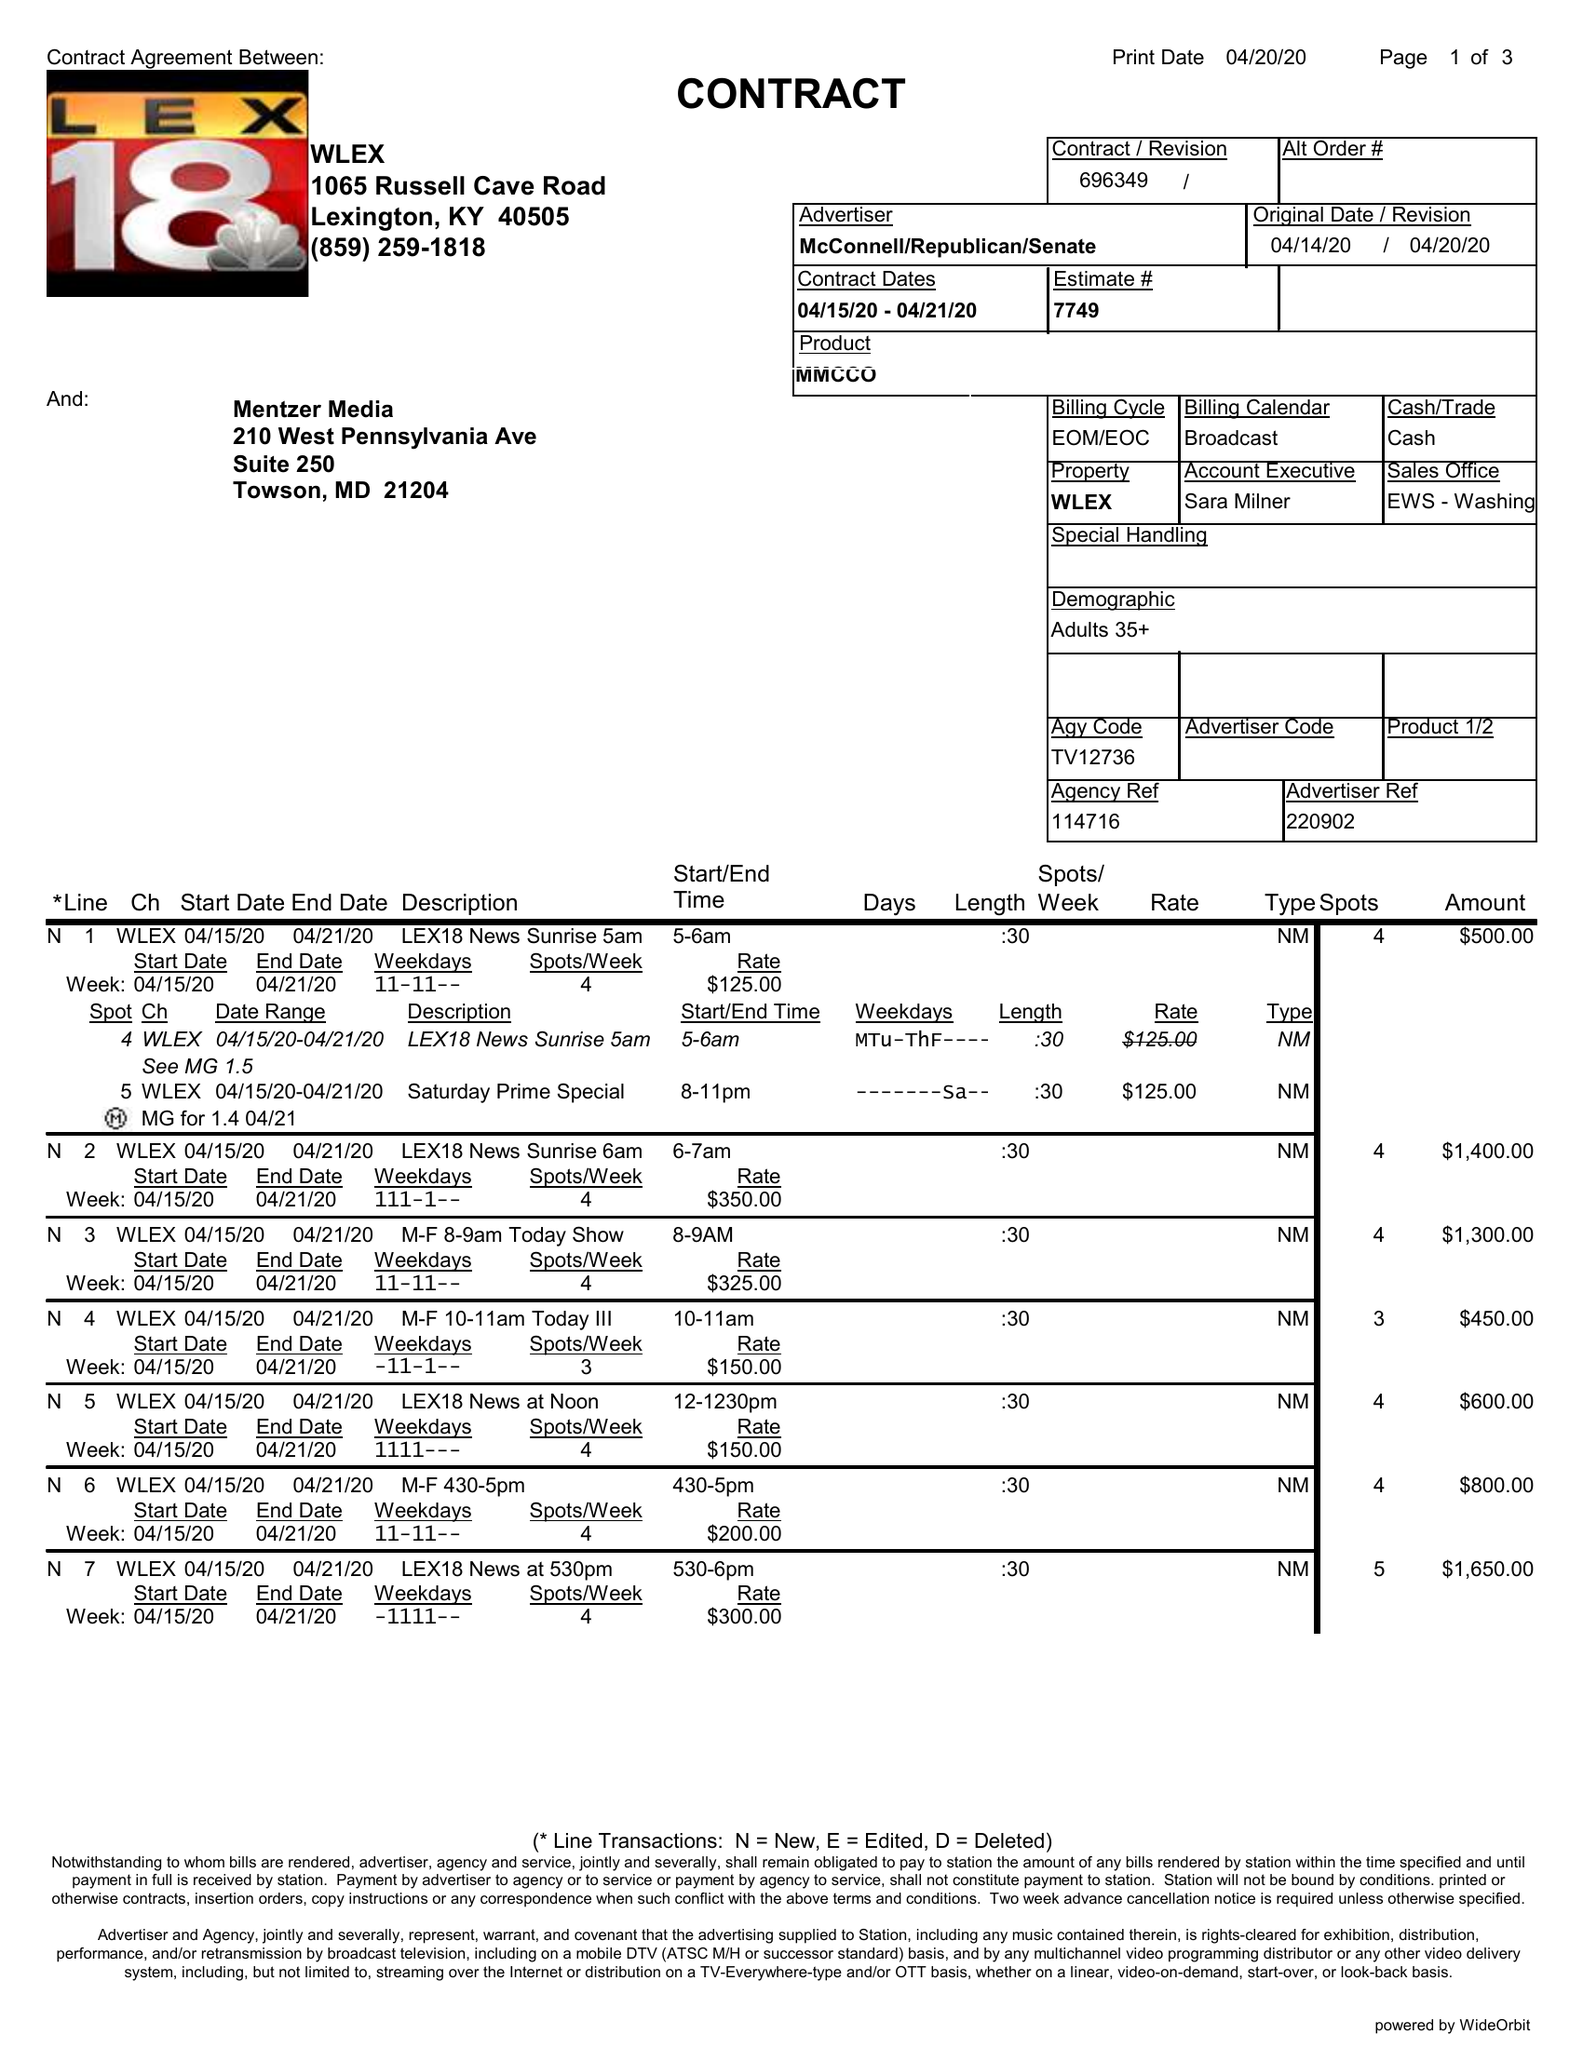What is the value for the gross_amount?
Answer the question using a single word or phrase. 14675.00 